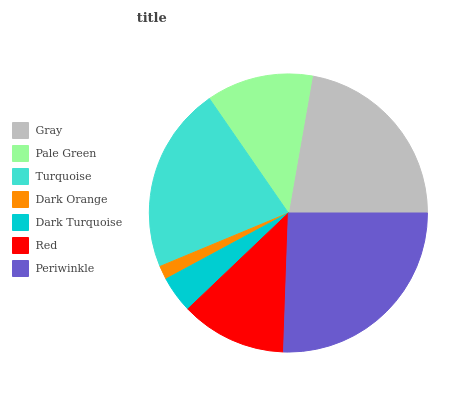Is Dark Orange the minimum?
Answer yes or no. Yes. Is Periwinkle the maximum?
Answer yes or no. Yes. Is Pale Green the minimum?
Answer yes or no. No. Is Pale Green the maximum?
Answer yes or no. No. Is Gray greater than Pale Green?
Answer yes or no. Yes. Is Pale Green less than Gray?
Answer yes or no. Yes. Is Pale Green greater than Gray?
Answer yes or no. No. Is Gray less than Pale Green?
Answer yes or no. No. Is Pale Green the high median?
Answer yes or no. Yes. Is Pale Green the low median?
Answer yes or no. Yes. Is Dark Orange the high median?
Answer yes or no. No. Is Red the low median?
Answer yes or no. No. 